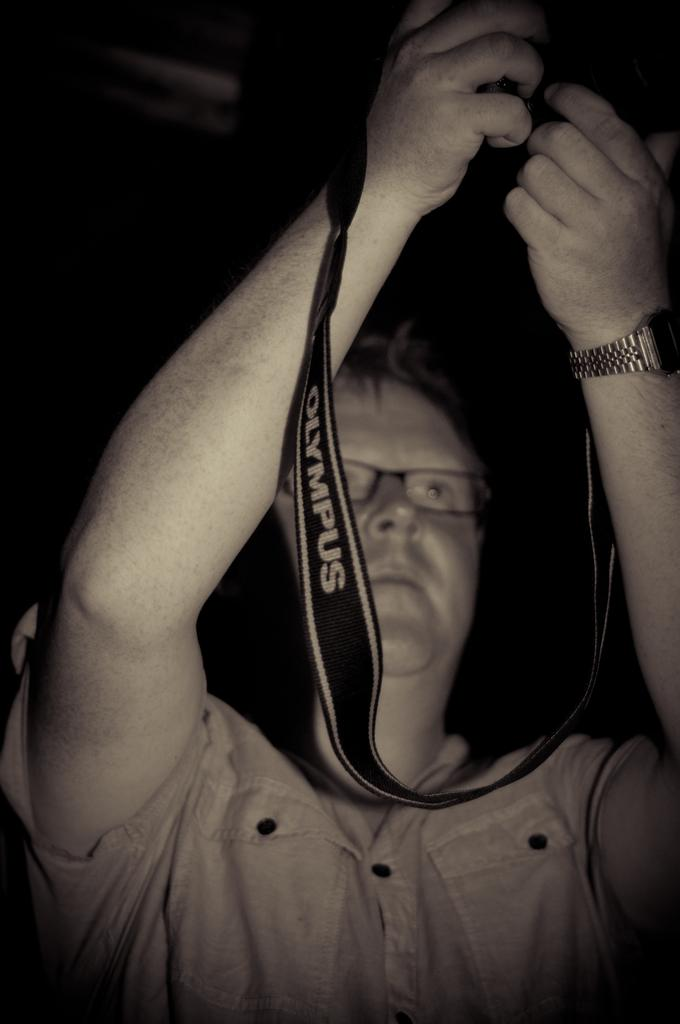What is the main subject of the image? There is a man in the center of the image. What is the man holding in his hand? The man is holding a camera in his hand. What type of animal can be seen whistling in the image? There is no animal present in the image, nor is there any whistling. 